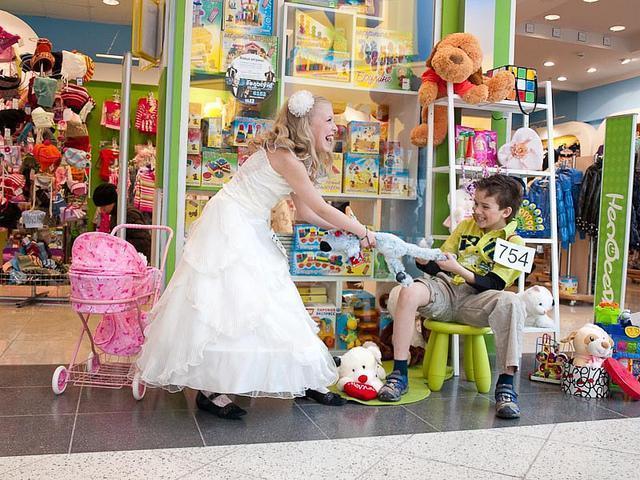How many people are there?
Give a very brief answer. 2. How many teddy bears are there?
Give a very brief answer. 2. How many televisions are on the left of the door?
Give a very brief answer. 0. 